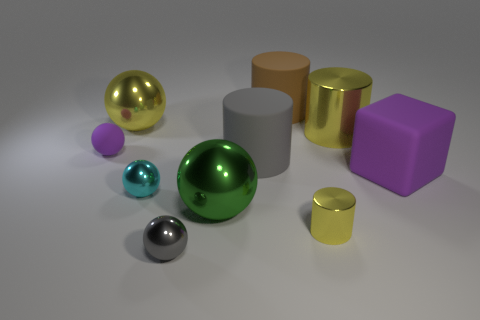Is there a tiny matte sphere of the same color as the big metallic cylinder?
Make the answer very short. No. What is the color of the cylinder that is the same size as the cyan sphere?
Keep it short and to the point. Yellow. There is a matte thing that is to the right of the brown cylinder; is its color the same as the tiny matte sphere?
Provide a short and direct response. Yes. Are there any tiny objects that have the same material as the large gray cylinder?
Give a very brief answer. Yes. What shape is the tiny object that is the same color as the big metallic cylinder?
Your answer should be compact. Cylinder. Is the number of big purple cubes behind the tiny rubber thing less than the number of big brown spheres?
Your answer should be very brief. No. Is the size of the purple object on the right side of the gray cylinder the same as the cyan metallic thing?
Give a very brief answer. No. How many big yellow rubber things have the same shape as the small purple thing?
Your answer should be compact. 0. The cyan thing that is the same material as the large green thing is what size?
Offer a very short reply. Small. Is the number of small cylinders in front of the small gray object the same as the number of large purple rubber cubes?
Ensure brevity in your answer.  No. 